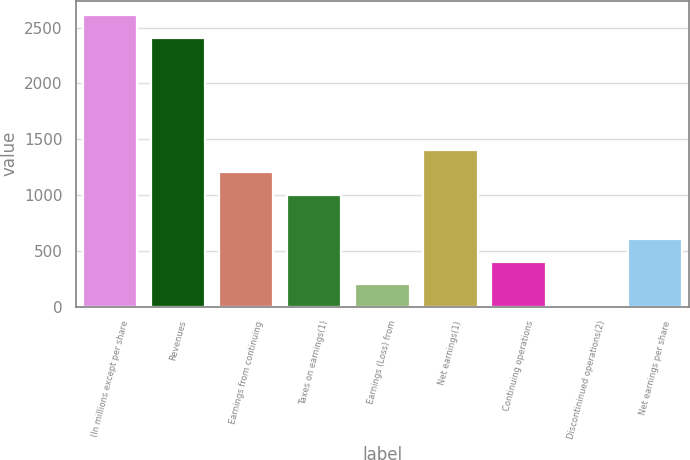<chart> <loc_0><loc_0><loc_500><loc_500><bar_chart><fcel>(In millions except per share<fcel>Revenues<fcel>Earnings from continuing<fcel>Taxes on earnings(1)<fcel>Earnings (Loss) from<fcel>Net earnings(1)<fcel>Continuing operations<fcel>Discontininued operations(2)<fcel>Net earnings per share<nl><fcel>2607.81<fcel>2407.21<fcel>1203.61<fcel>1003.01<fcel>200.61<fcel>1404.21<fcel>401.21<fcel>0.01<fcel>601.81<nl></chart> 